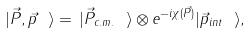Convert formula to latex. <formula><loc_0><loc_0><loc_500><loc_500>| { \vec { P } , \vec { p } } \ \rangle = \, | { \vec { P } } _ { c . m . } \ \rangle \otimes e ^ { - i \chi ( \vec { P } ) } | { \vec { p } } _ { i n t } \ \rangle ,</formula> 